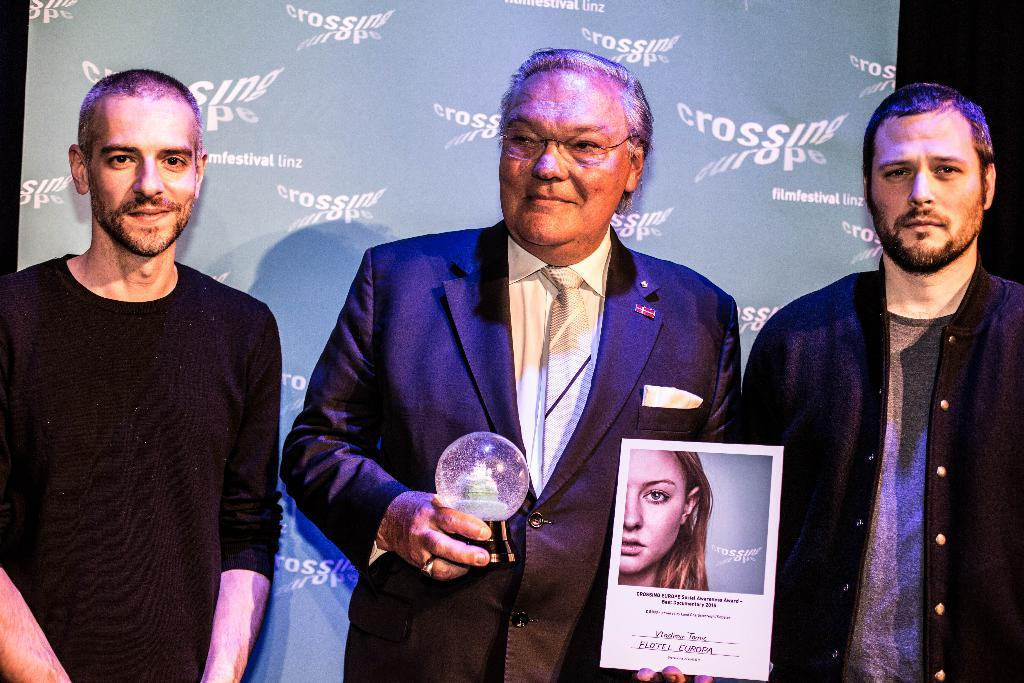How many people are in the image? There are three men in the image. What is the middle man holding in his hands? The middle man is holding a poster and an object in his hands. What can be seen behind the middle man? There is a hoarding visible behind the middle man. Can you tell me how many horses are present in the image? There are no horses present in the image. What type of stocking is the man wearing on his left leg? There is no information about any stockings or legs in the image. 